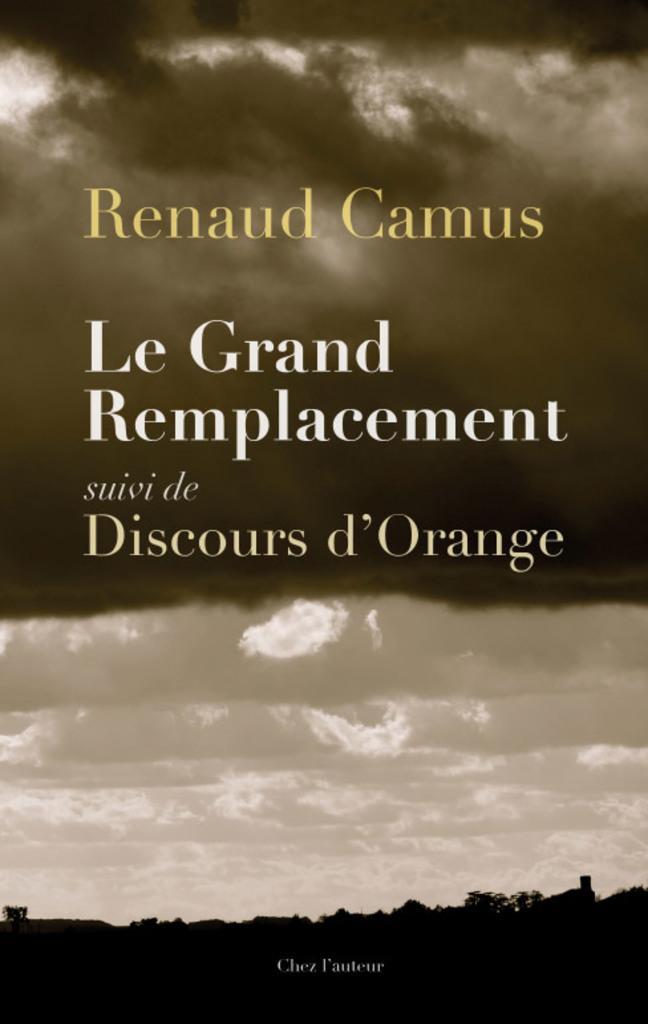Can you describe this image briefly? In this image I can see a poster and something is written on it. Background is in white,brown and black color. 